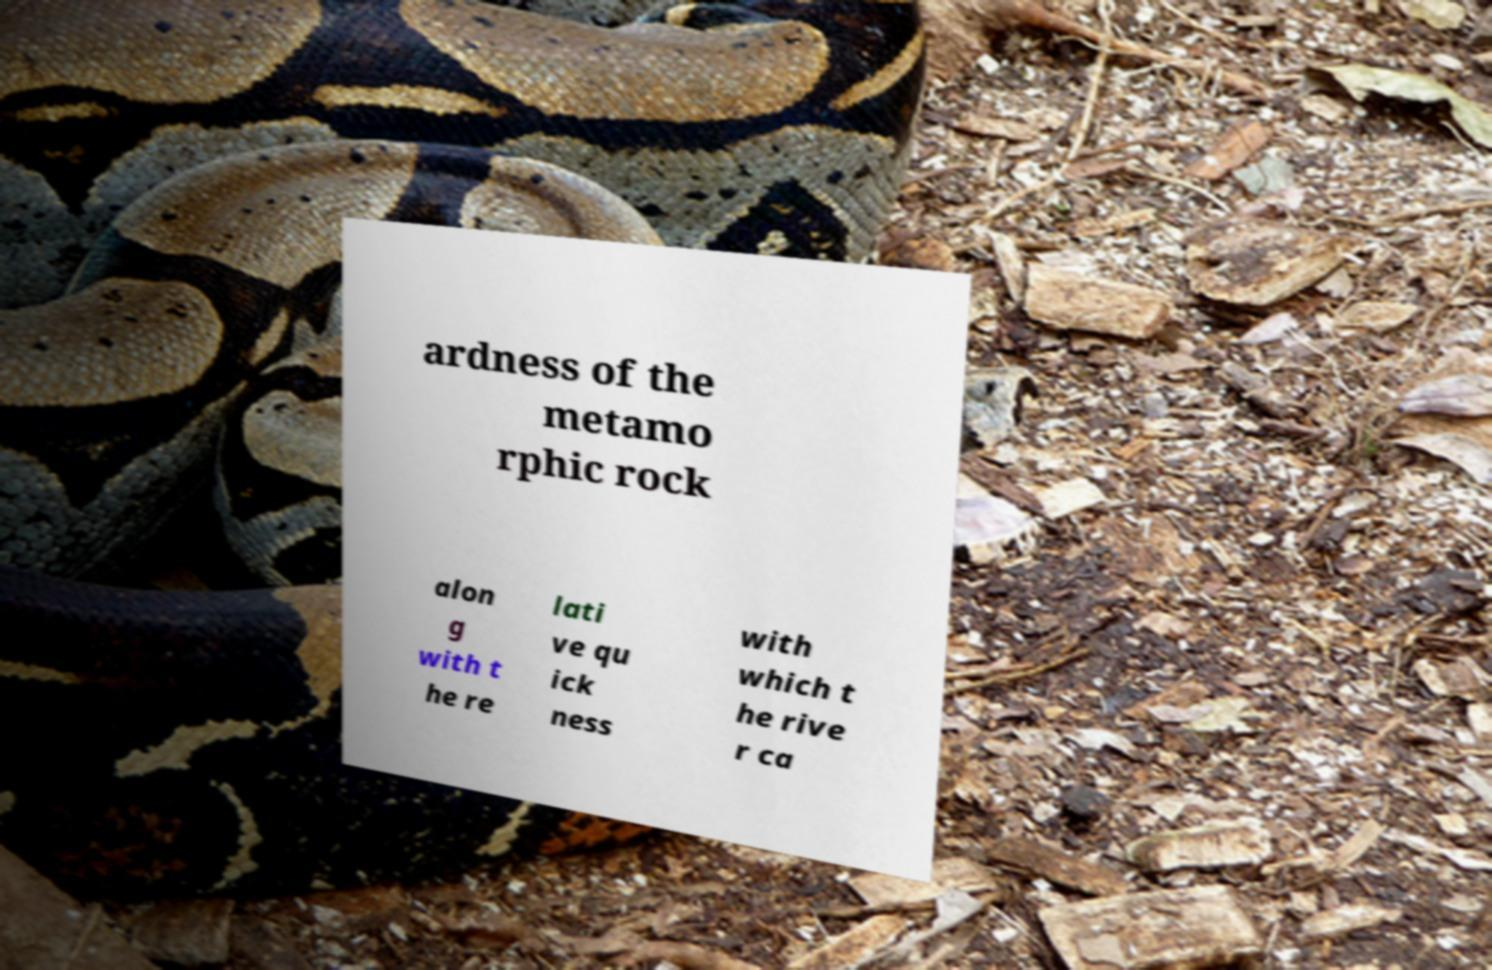Can you read and provide the text displayed in the image?This photo seems to have some interesting text. Can you extract and type it out for me? ardness of the metamo rphic rock alon g with t he re lati ve qu ick ness with which t he rive r ca 